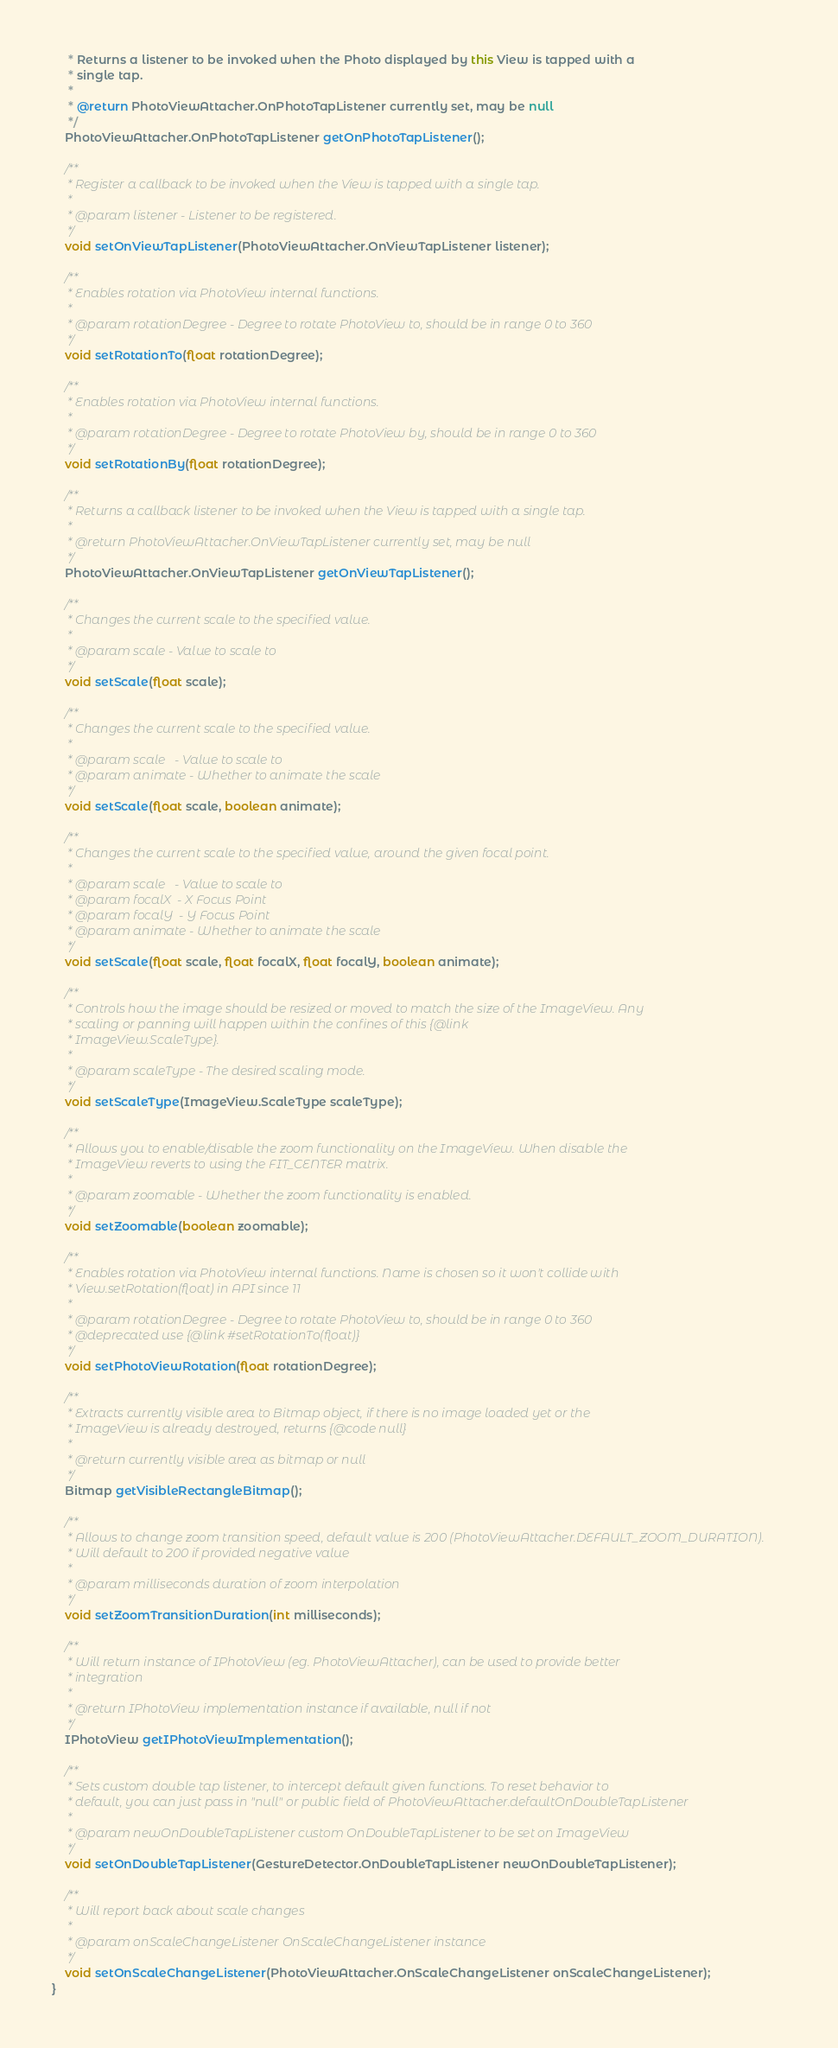<code> <loc_0><loc_0><loc_500><loc_500><_Java_>     * Returns a listener to be invoked when the Photo displayed by this View is tapped with a
     * single tap.
     *
     * @return PhotoViewAttacher.OnPhotoTapListener currently set, may be null
     */
    PhotoViewAttacher.OnPhotoTapListener getOnPhotoTapListener();

    /**
     * Register a callback to be invoked when the View is tapped with a single tap.
     *
     * @param listener - Listener to be registered.
     */
    void setOnViewTapListener(PhotoViewAttacher.OnViewTapListener listener);

    /**
     * Enables rotation via PhotoView internal functions.
     *
     * @param rotationDegree - Degree to rotate PhotoView to, should be in range 0 to 360
     */
    void setRotationTo(float rotationDegree);

    /**
     * Enables rotation via PhotoView internal functions.
     *
     * @param rotationDegree - Degree to rotate PhotoView by, should be in range 0 to 360
     */
    void setRotationBy(float rotationDegree);

    /**
     * Returns a callback listener to be invoked when the View is tapped with a single tap.
     *
     * @return PhotoViewAttacher.OnViewTapListener currently set, may be null
     */
    PhotoViewAttacher.OnViewTapListener getOnViewTapListener();

    /**
     * Changes the current scale to the specified value.
     *
     * @param scale - Value to scale to
     */
    void setScale(float scale);

    /**
     * Changes the current scale to the specified value.
     *
     * @param scale   - Value to scale to
     * @param animate - Whether to animate the scale
     */
    void setScale(float scale, boolean animate);

    /**
     * Changes the current scale to the specified value, around the given focal point.
     *
     * @param scale   - Value to scale to
     * @param focalX  - X Focus Point
     * @param focalY  - Y Focus Point
     * @param animate - Whether to animate the scale
     */
    void setScale(float scale, float focalX, float focalY, boolean animate);

    /**
     * Controls how the image should be resized or moved to match the size of the ImageView. Any
     * scaling or panning will happen within the confines of this {@link
     * ImageView.ScaleType}.
     *
     * @param scaleType - The desired scaling mode.
     */
    void setScaleType(ImageView.ScaleType scaleType);

    /**
     * Allows you to enable/disable the zoom functionality on the ImageView. When disable the
     * ImageView reverts to using the FIT_CENTER matrix.
     *
     * @param zoomable - Whether the zoom functionality is enabled.
     */
    void setZoomable(boolean zoomable);

    /**
     * Enables rotation via PhotoView internal functions. Name is chosen so it won't collide with
     * View.setRotation(float) in API since 11
     *
     * @param rotationDegree - Degree to rotate PhotoView to, should be in range 0 to 360
     * @deprecated use {@link #setRotationTo(float)}
     */
    void setPhotoViewRotation(float rotationDegree);

    /**
     * Extracts currently visible area to Bitmap object, if there is no image loaded yet or the
     * ImageView is already destroyed, returns {@code null}
     *
     * @return currently visible area as bitmap or null
     */
    Bitmap getVisibleRectangleBitmap();

    /**
     * Allows to change zoom transition speed, default value is 200 (PhotoViewAttacher.DEFAULT_ZOOM_DURATION).
     * Will default to 200 if provided negative value
     *
     * @param milliseconds duration of zoom interpolation
     */
    void setZoomTransitionDuration(int milliseconds);

    /**
     * Will return instance of IPhotoView (eg. PhotoViewAttacher), can be used to provide better
     * integration
     *
     * @return IPhotoView implementation instance if available, null if not
     */
    IPhotoView getIPhotoViewImplementation();

    /**
     * Sets custom double tap listener, to intercept default given functions. To reset behavior to
     * default, you can just pass in "null" or public field of PhotoViewAttacher.defaultOnDoubleTapListener
     *
     * @param newOnDoubleTapListener custom OnDoubleTapListener to be set on ImageView
     */
    void setOnDoubleTapListener(GestureDetector.OnDoubleTapListener newOnDoubleTapListener);

    /**
     * Will report back about scale changes
     *
     * @param onScaleChangeListener OnScaleChangeListener instance
     */
    void setOnScaleChangeListener(PhotoViewAttacher.OnScaleChangeListener onScaleChangeListener);
}
</code> 